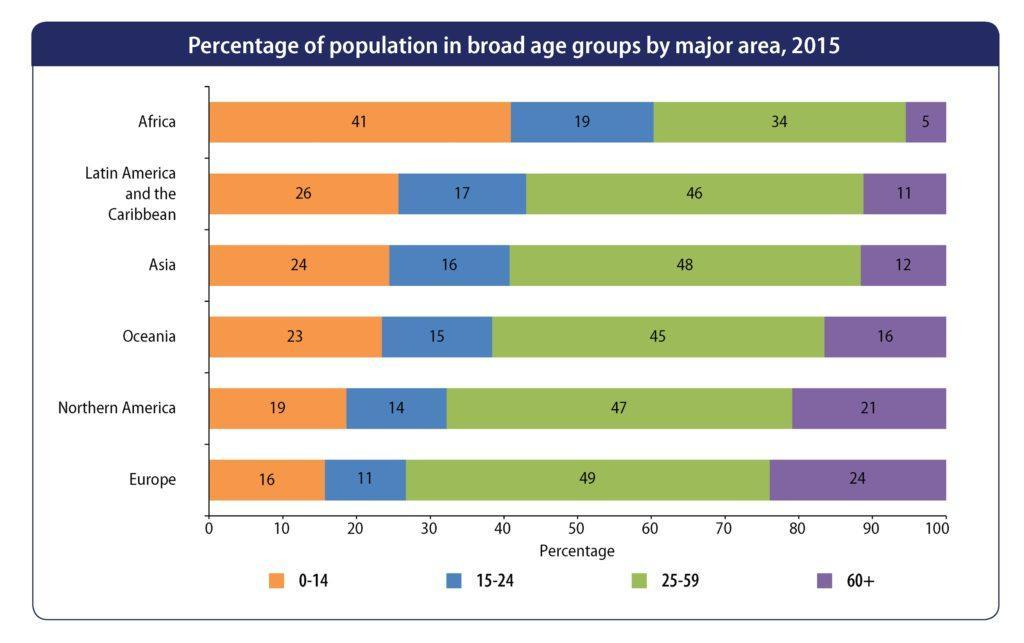what is the percentage of population of age below 15 in Asia?
Answer the question with a short phrase. 24 what is the percentage of population of age above 60 in Oceania? 16% Which is the most populous age group in Africa? 0-14 Which is the least populous age group in Oceania? 15-24 what is the percentage of population of age between 25 and 59 in Africa? 34% Which is the least populous age group in Latin America and the Caribbean? 60+ Which is the least populous age group in Northern America? 14 what is the total percent of people under 60 in Asia? 88% what is the total percent of people of age 25 or above in Europe? 73% Which is the most populous age group in Asia? 25-59 Which is the most populous age group in Europe? 25-59 what is the total percent of people of age between 0 and 24 in Oceania? 38 what is the total percent of people under 25 in Africa? 60 what is the percentage of population of age between 25 and 59 in Northern America? 47% what is the percentage of population of age between 15 and 24 in Europe? 11 